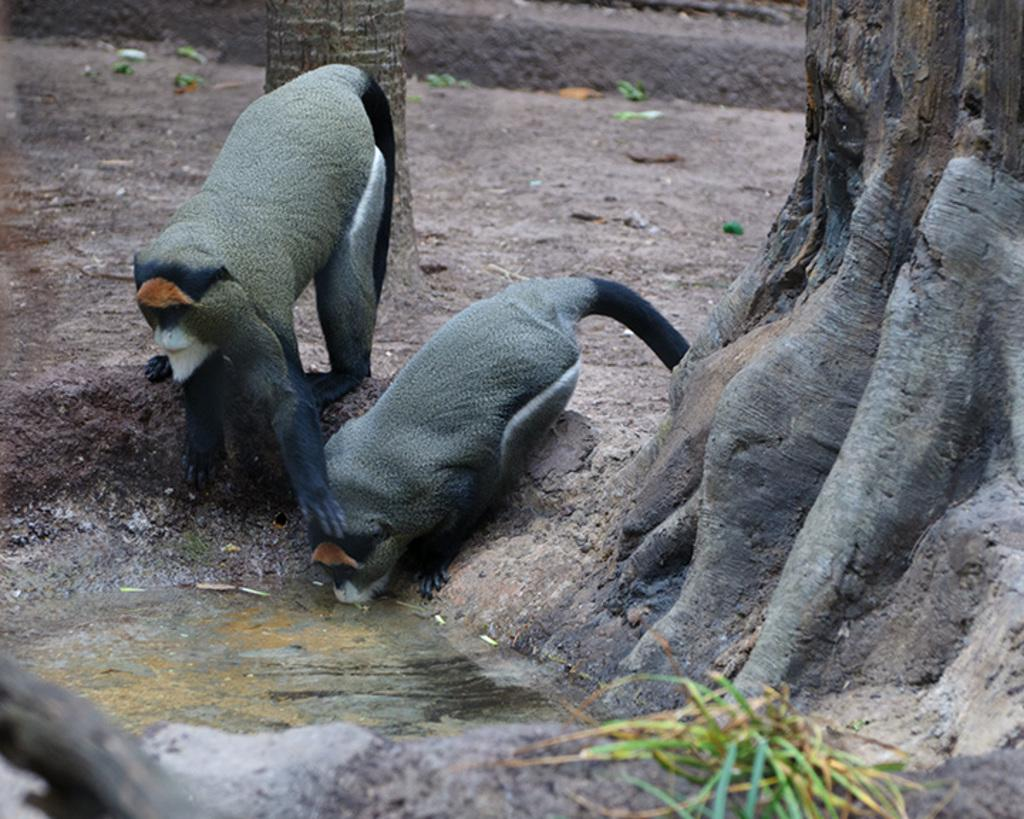How many monkeys are present in the image? There are two monkeys in the image. What is the right side monkey doing? The right side monkey is drinking water. What can be seen in the background of the image? There are trees in the background of the image. What type of cord is being used by the monkeys in the image? There is no cord present in the image; the monkeys are not using any cords. 